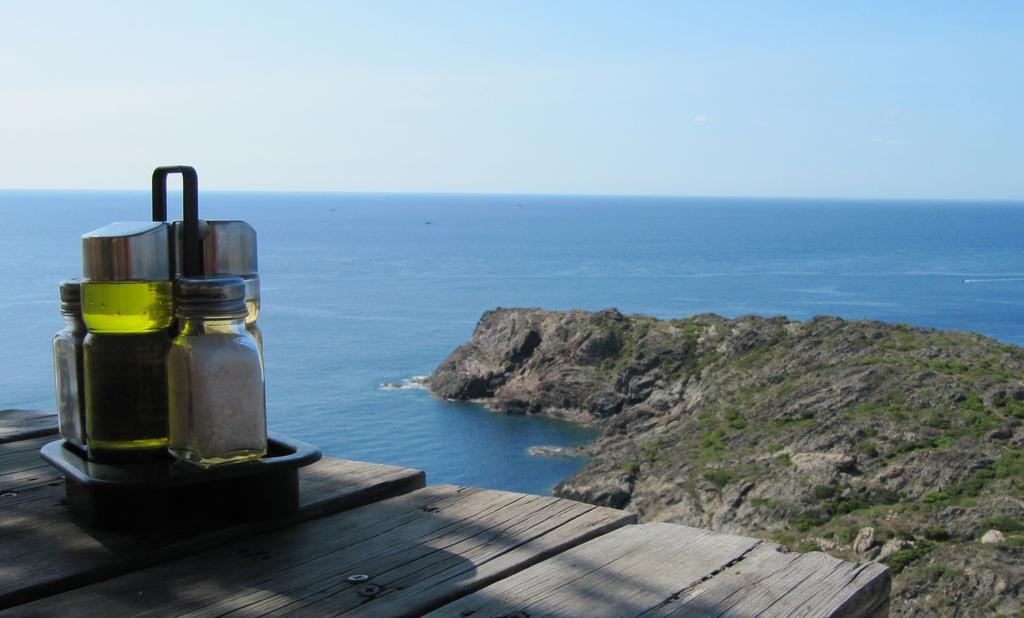Could you give a brief overview of what you see in this image? on the table there are some bottles present on it there is a near to it we can see clear sky. 